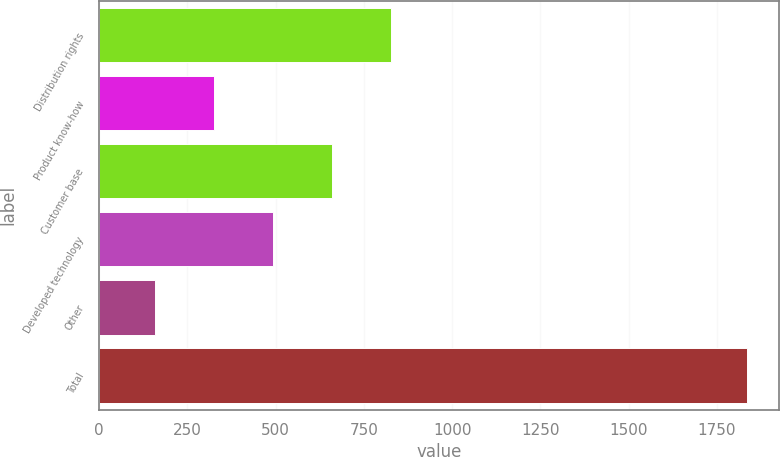Convert chart to OTSL. <chart><loc_0><loc_0><loc_500><loc_500><bar_chart><fcel>Distribution rights<fcel>Product know-how<fcel>Customer base<fcel>Developed technology<fcel>Other<fcel>Total<nl><fcel>827.8<fcel>324.7<fcel>660.1<fcel>492.4<fcel>157<fcel>1834<nl></chart> 